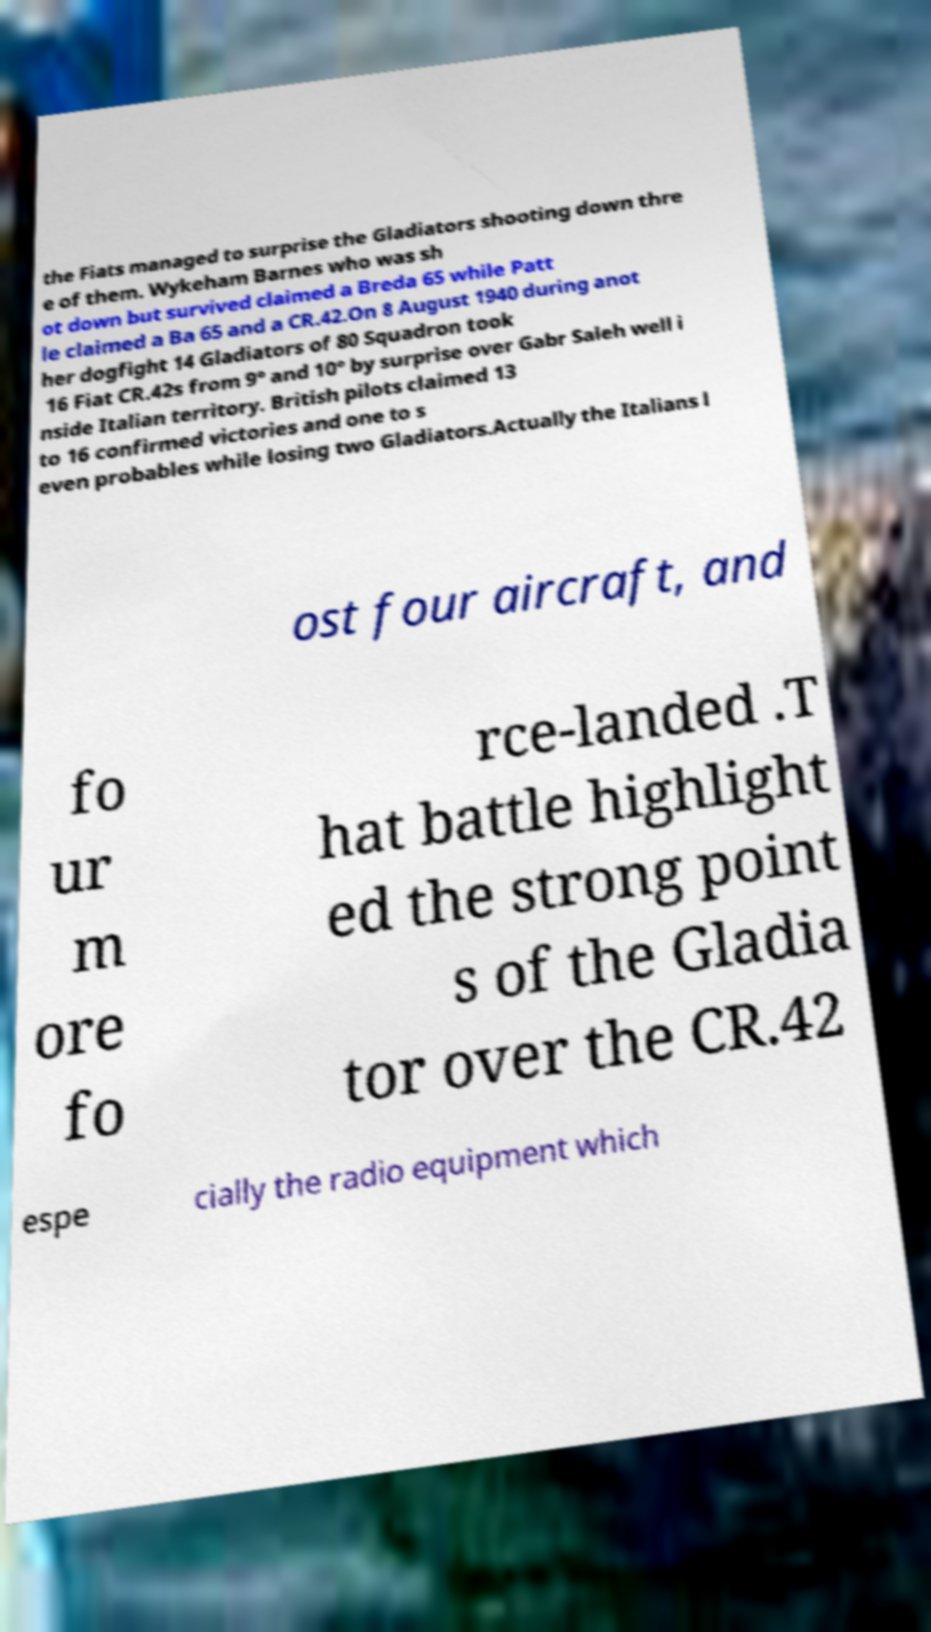For documentation purposes, I need the text within this image transcribed. Could you provide that? the Fiats managed to surprise the Gladiators shooting down thre e of them. Wykeham Barnes who was sh ot down but survived claimed a Breda 65 while Patt le claimed a Ba 65 and a CR.42.On 8 August 1940 during anot her dogfight 14 Gladiators of 80 Squadron took 16 Fiat CR.42s from 9° and 10° by surprise over Gabr Saleh well i nside Italian territory. British pilots claimed 13 to 16 confirmed victories and one to s even probables while losing two Gladiators.Actually the Italians l ost four aircraft, and fo ur m ore fo rce-landed .T hat battle highlight ed the strong point s of the Gladia tor over the CR.42 espe cially the radio equipment which 